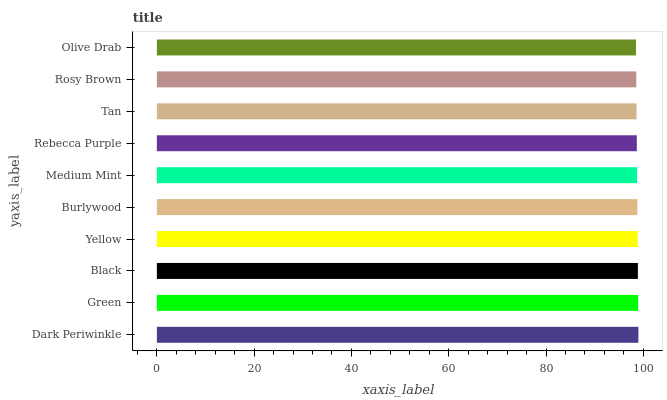Is Olive Drab the minimum?
Answer yes or no. Yes. Is Dark Periwinkle the maximum?
Answer yes or no. Yes. Is Green the minimum?
Answer yes or no. No. Is Green the maximum?
Answer yes or no. No. Is Dark Periwinkle greater than Green?
Answer yes or no. Yes. Is Green less than Dark Periwinkle?
Answer yes or no. Yes. Is Green greater than Dark Periwinkle?
Answer yes or no. No. Is Dark Periwinkle less than Green?
Answer yes or no. No. Is Burlywood the high median?
Answer yes or no. Yes. Is Medium Mint the low median?
Answer yes or no. Yes. Is Medium Mint the high median?
Answer yes or no. No. Is Dark Periwinkle the low median?
Answer yes or no. No. 